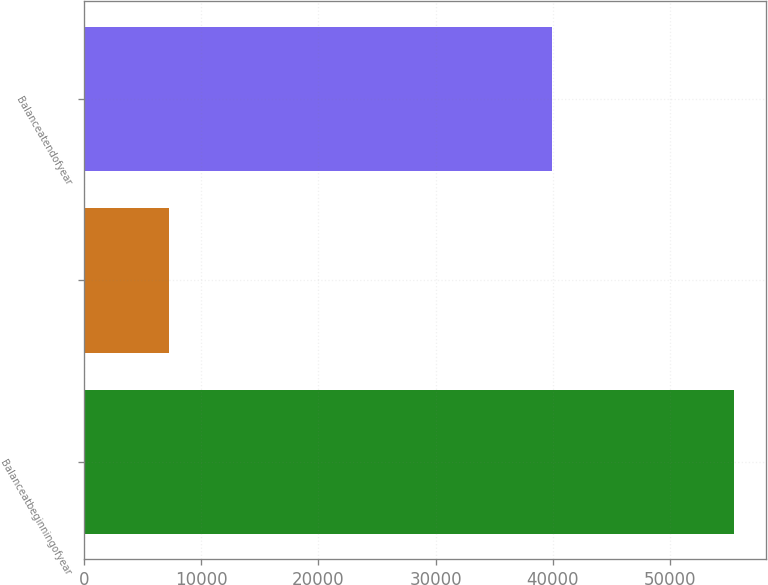Convert chart. <chart><loc_0><loc_0><loc_500><loc_500><bar_chart><fcel>Balanceatbeginningofyear<fcel>Unnamed: 1<fcel>Balanceatendofyear<nl><fcel>55459<fcel>7224.2<fcel>39939.2<nl></chart> 